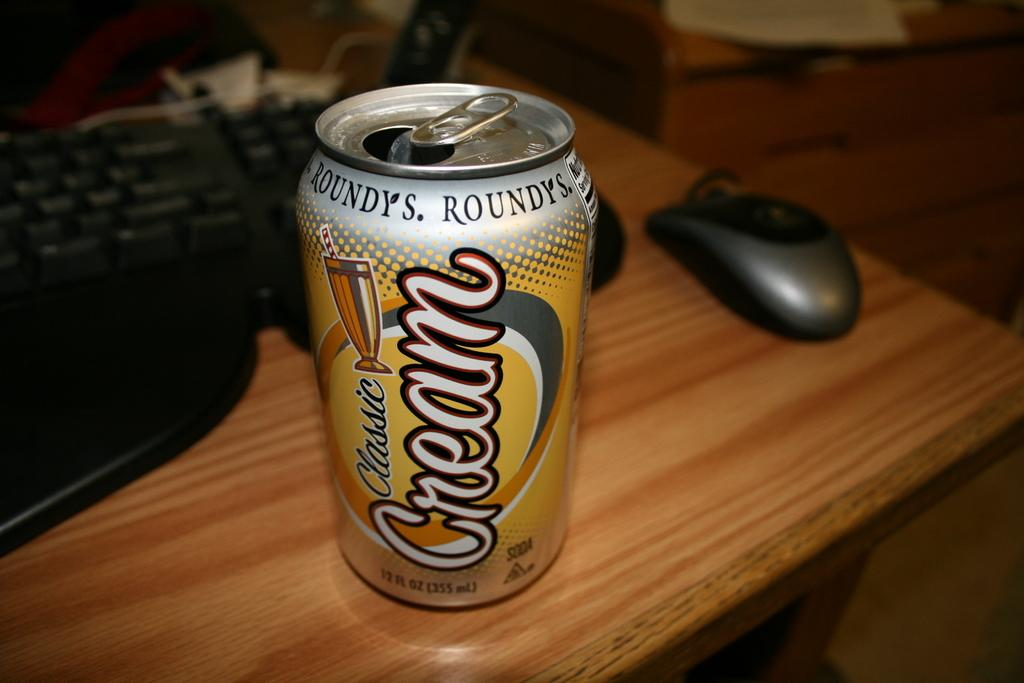<image>
Create a compact narrative representing the image presented. a can of cream soda that is on a brown table 